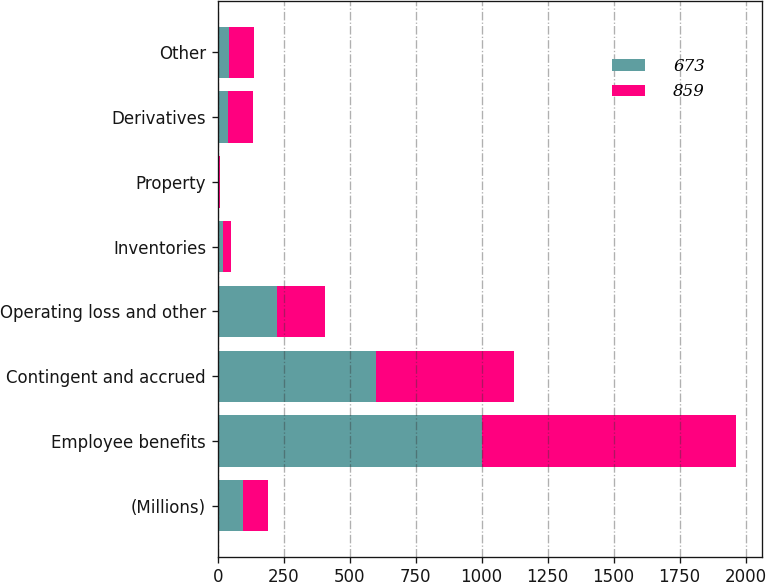Convert chart to OTSL. <chart><loc_0><loc_0><loc_500><loc_500><stacked_bar_chart><ecel><fcel>(Millions)<fcel>Employee benefits<fcel>Contingent and accrued<fcel>Operating loss and other<fcel>Inventories<fcel>Property<fcel>Derivatives<fcel>Other<nl><fcel>673<fcel>96<fcel>1000<fcel>598<fcel>223<fcel>21<fcel>5<fcel>38<fcel>41<nl><fcel>859<fcel>96<fcel>963<fcel>524<fcel>183<fcel>29<fcel>3<fcel>95<fcel>97<nl></chart> 